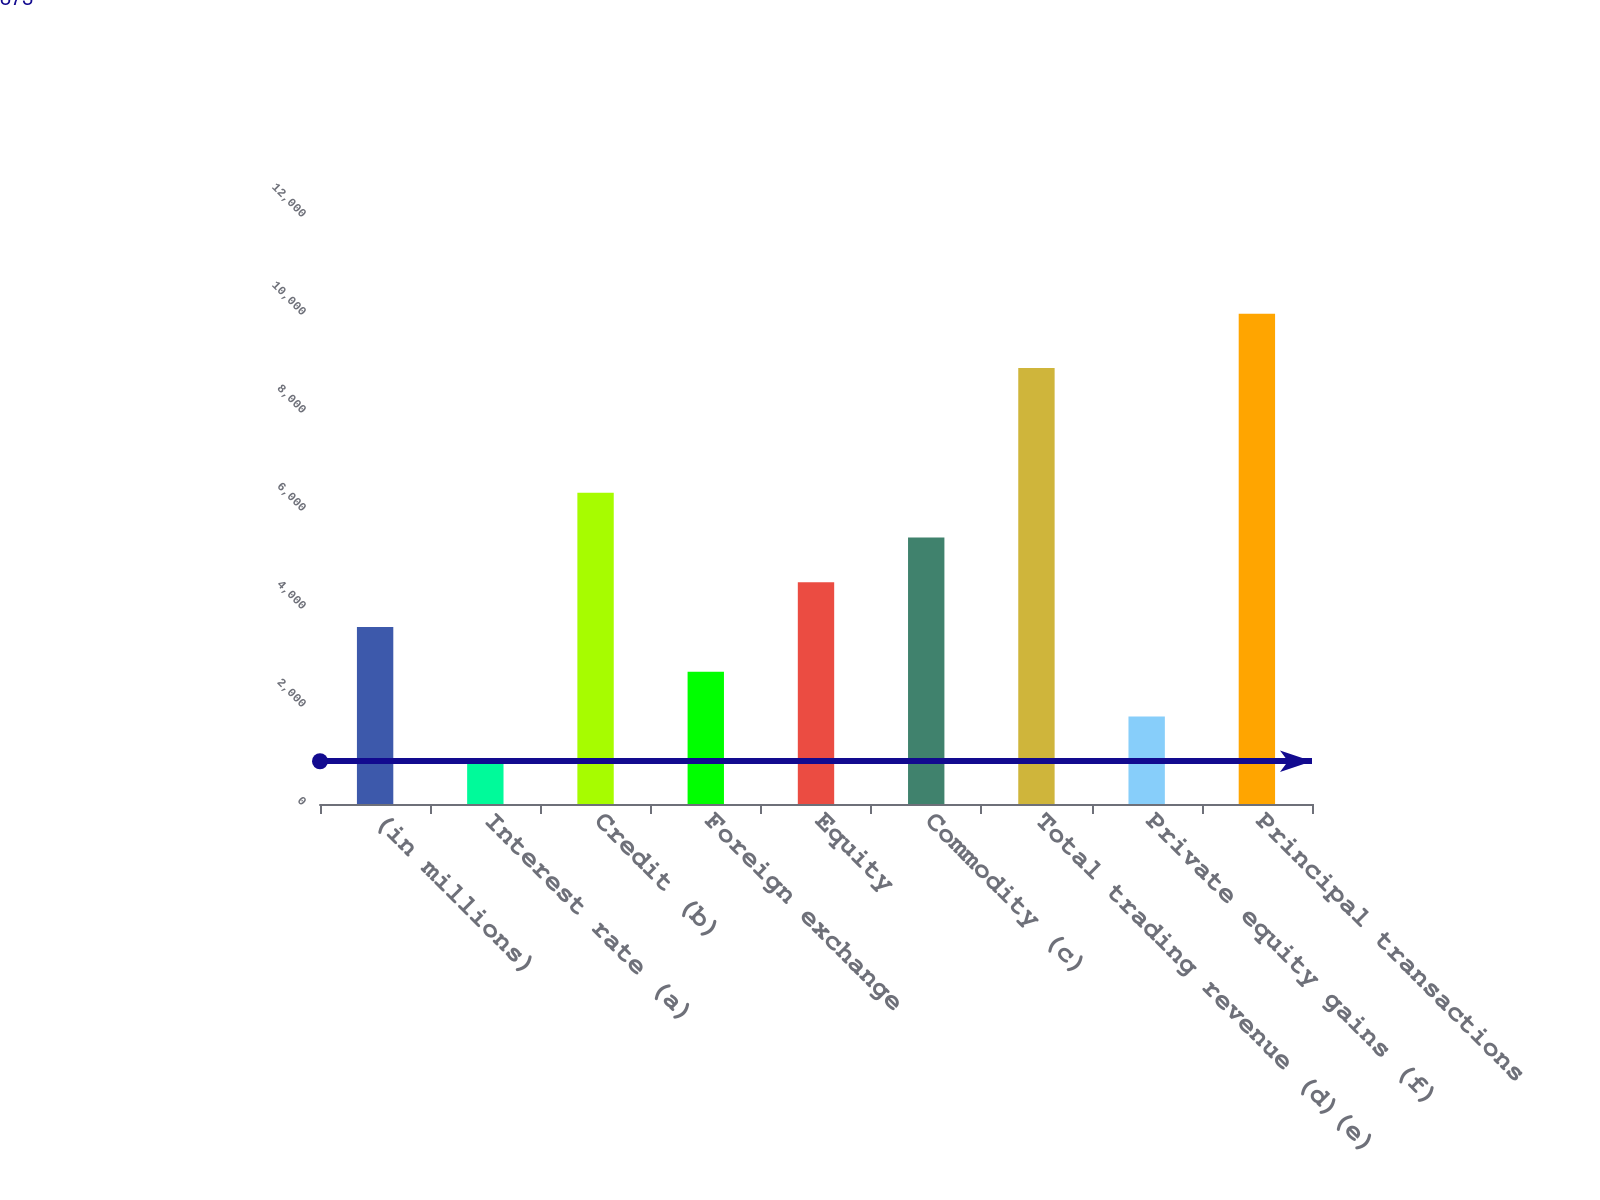Convert chart to OTSL. <chart><loc_0><loc_0><loc_500><loc_500><bar_chart><fcel>(in millions)<fcel>Interest rate (a)<fcel>Credit (b)<fcel>Foreign exchange<fcel>Equity<fcel>Commodity (c)<fcel>Total trading revenue (d)(e)<fcel>Private equity gains (f)<fcel>Principal transactions<nl><fcel>3612.6<fcel>873<fcel>6352.2<fcel>2699.4<fcel>4525.8<fcel>5439<fcel>8898<fcel>1786.2<fcel>10005<nl></chart> 